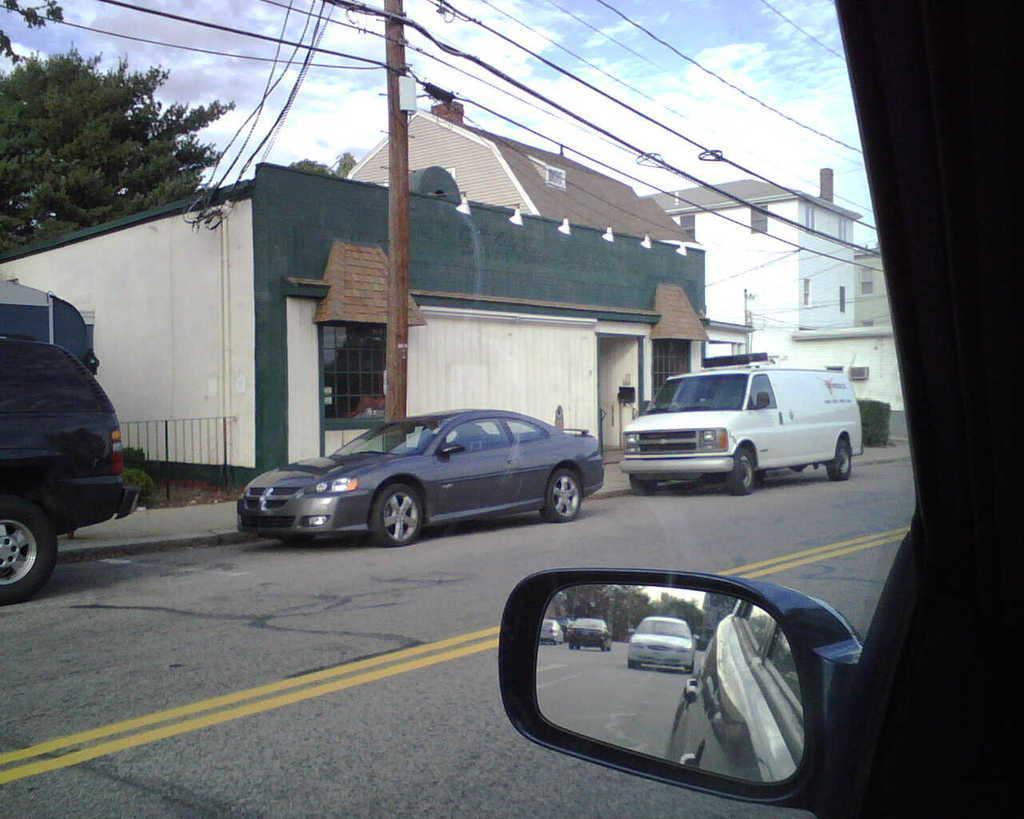Please provide a concise description of this image. This picture is taken from the glass of a vehicle and I can see few buildings, trees and few cars parked on the road and I can see a blue cloudy sky and a pole and in the side mirror of the vehicle I can see few cars moving on the road and trees. 